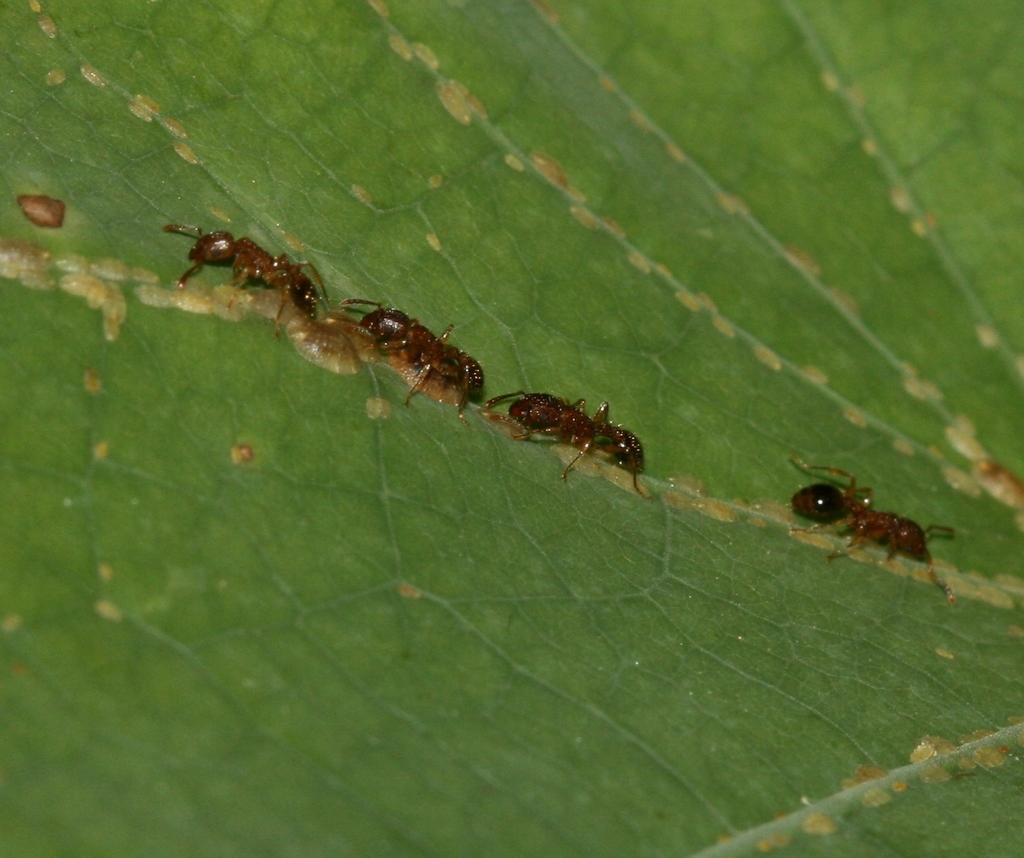How many ants are present in the image? There are four ants in the image. Where are the ants located in the image? The ants are on a leaf. What type of attention is the ants giving to the straw in the image? There is no straw present in the image, and therefore no interaction between the ants and a straw can be observed. 